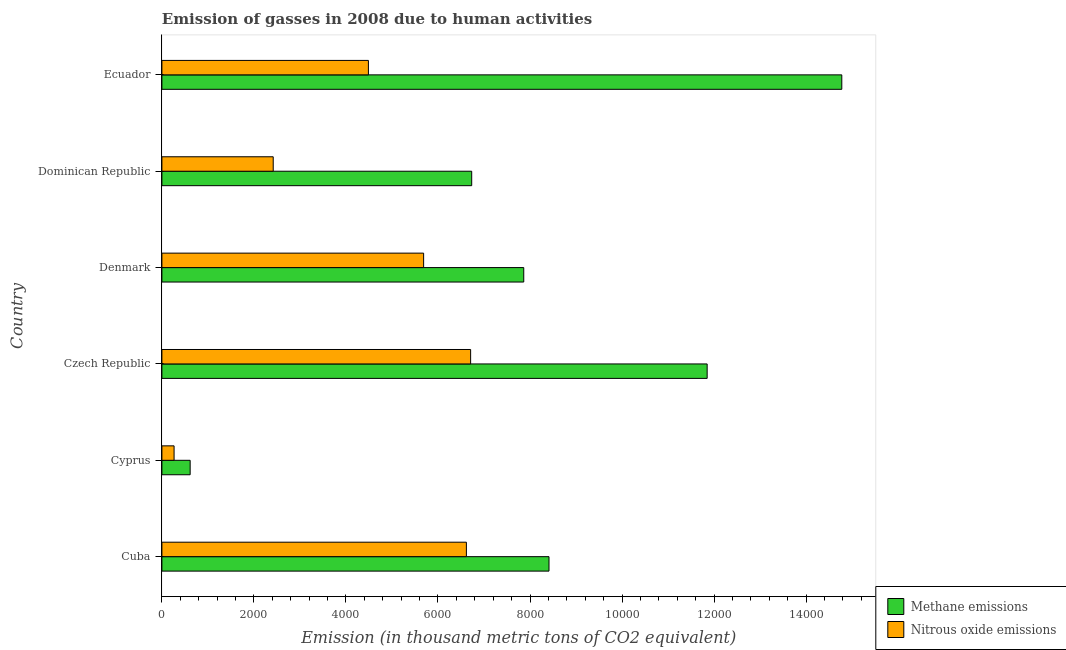Are the number of bars per tick equal to the number of legend labels?
Provide a short and direct response. Yes. What is the label of the 5th group of bars from the top?
Provide a succinct answer. Cyprus. What is the amount of methane emissions in Ecuador?
Your answer should be very brief. 1.48e+04. Across all countries, what is the maximum amount of methane emissions?
Your response must be concise. 1.48e+04. Across all countries, what is the minimum amount of methane emissions?
Ensure brevity in your answer.  614.2. In which country was the amount of methane emissions maximum?
Your answer should be compact. Ecuador. In which country was the amount of methane emissions minimum?
Make the answer very short. Cyprus. What is the total amount of methane emissions in the graph?
Provide a succinct answer. 5.03e+04. What is the difference between the amount of methane emissions in Cuba and that in Cyprus?
Provide a succinct answer. 7798.9. What is the difference between the amount of nitrous oxide emissions in Cyprus and the amount of methane emissions in Cuba?
Provide a short and direct response. -8148.6. What is the average amount of methane emissions per country?
Offer a terse response. 8375.22. What is the difference between the amount of nitrous oxide emissions and amount of methane emissions in Cuba?
Your response must be concise. -1795.6. In how many countries, is the amount of nitrous oxide emissions greater than 4800 thousand metric tons?
Keep it short and to the point. 3. What is the ratio of the amount of nitrous oxide emissions in Cuba to that in Denmark?
Offer a very short reply. 1.16. Is the difference between the amount of methane emissions in Cyprus and Ecuador greater than the difference between the amount of nitrous oxide emissions in Cyprus and Ecuador?
Your answer should be compact. No. What is the difference between the highest and the second highest amount of nitrous oxide emissions?
Provide a succinct answer. 92.2. What is the difference between the highest and the lowest amount of methane emissions?
Your answer should be compact. 1.42e+04. What does the 1st bar from the top in Czech Republic represents?
Make the answer very short. Nitrous oxide emissions. What does the 1st bar from the bottom in Cuba represents?
Provide a succinct answer. Methane emissions. How many bars are there?
Give a very brief answer. 12. Are all the bars in the graph horizontal?
Make the answer very short. Yes. How many countries are there in the graph?
Offer a very short reply. 6. What is the difference between two consecutive major ticks on the X-axis?
Offer a very short reply. 2000. Are the values on the major ticks of X-axis written in scientific E-notation?
Offer a terse response. No. Does the graph contain any zero values?
Provide a short and direct response. No. Does the graph contain grids?
Provide a succinct answer. No. Where does the legend appear in the graph?
Your response must be concise. Bottom right. How are the legend labels stacked?
Your answer should be compact. Vertical. What is the title of the graph?
Give a very brief answer. Emission of gasses in 2008 due to human activities. Does "Arms exports" appear as one of the legend labels in the graph?
Keep it short and to the point. No. What is the label or title of the X-axis?
Offer a terse response. Emission (in thousand metric tons of CO2 equivalent). What is the Emission (in thousand metric tons of CO2 equivalent) in Methane emissions in Cuba?
Offer a terse response. 8413.1. What is the Emission (in thousand metric tons of CO2 equivalent) in Nitrous oxide emissions in Cuba?
Your response must be concise. 6617.5. What is the Emission (in thousand metric tons of CO2 equivalent) in Methane emissions in Cyprus?
Your response must be concise. 614.2. What is the Emission (in thousand metric tons of CO2 equivalent) of Nitrous oxide emissions in Cyprus?
Provide a short and direct response. 264.5. What is the Emission (in thousand metric tons of CO2 equivalent) in Methane emissions in Czech Republic?
Provide a succinct answer. 1.19e+04. What is the Emission (in thousand metric tons of CO2 equivalent) of Nitrous oxide emissions in Czech Republic?
Offer a terse response. 6709.7. What is the Emission (in thousand metric tons of CO2 equivalent) of Methane emissions in Denmark?
Offer a very short reply. 7864.1. What is the Emission (in thousand metric tons of CO2 equivalent) in Nitrous oxide emissions in Denmark?
Provide a succinct answer. 5688.2. What is the Emission (in thousand metric tons of CO2 equivalent) in Methane emissions in Dominican Republic?
Provide a succinct answer. 6733.1. What is the Emission (in thousand metric tons of CO2 equivalent) in Nitrous oxide emissions in Dominican Republic?
Ensure brevity in your answer.  2419.2. What is the Emission (in thousand metric tons of CO2 equivalent) of Methane emissions in Ecuador?
Give a very brief answer. 1.48e+04. What is the Emission (in thousand metric tons of CO2 equivalent) in Nitrous oxide emissions in Ecuador?
Make the answer very short. 4488.1. Across all countries, what is the maximum Emission (in thousand metric tons of CO2 equivalent) of Methane emissions?
Offer a very short reply. 1.48e+04. Across all countries, what is the maximum Emission (in thousand metric tons of CO2 equivalent) in Nitrous oxide emissions?
Make the answer very short. 6709.7. Across all countries, what is the minimum Emission (in thousand metric tons of CO2 equivalent) of Methane emissions?
Offer a terse response. 614.2. Across all countries, what is the minimum Emission (in thousand metric tons of CO2 equivalent) in Nitrous oxide emissions?
Your response must be concise. 264.5. What is the total Emission (in thousand metric tons of CO2 equivalent) of Methane emissions in the graph?
Make the answer very short. 5.03e+04. What is the total Emission (in thousand metric tons of CO2 equivalent) in Nitrous oxide emissions in the graph?
Offer a terse response. 2.62e+04. What is the difference between the Emission (in thousand metric tons of CO2 equivalent) in Methane emissions in Cuba and that in Cyprus?
Your answer should be compact. 7798.9. What is the difference between the Emission (in thousand metric tons of CO2 equivalent) of Nitrous oxide emissions in Cuba and that in Cyprus?
Give a very brief answer. 6353. What is the difference between the Emission (in thousand metric tons of CO2 equivalent) in Methane emissions in Cuba and that in Czech Republic?
Offer a very short reply. -3437.3. What is the difference between the Emission (in thousand metric tons of CO2 equivalent) of Nitrous oxide emissions in Cuba and that in Czech Republic?
Offer a very short reply. -92.2. What is the difference between the Emission (in thousand metric tons of CO2 equivalent) in Methane emissions in Cuba and that in Denmark?
Your answer should be very brief. 549. What is the difference between the Emission (in thousand metric tons of CO2 equivalent) of Nitrous oxide emissions in Cuba and that in Denmark?
Offer a terse response. 929.3. What is the difference between the Emission (in thousand metric tons of CO2 equivalent) in Methane emissions in Cuba and that in Dominican Republic?
Provide a short and direct response. 1680. What is the difference between the Emission (in thousand metric tons of CO2 equivalent) of Nitrous oxide emissions in Cuba and that in Dominican Republic?
Provide a succinct answer. 4198.3. What is the difference between the Emission (in thousand metric tons of CO2 equivalent) in Methane emissions in Cuba and that in Ecuador?
Offer a terse response. -6363.3. What is the difference between the Emission (in thousand metric tons of CO2 equivalent) of Nitrous oxide emissions in Cuba and that in Ecuador?
Provide a short and direct response. 2129.4. What is the difference between the Emission (in thousand metric tons of CO2 equivalent) of Methane emissions in Cyprus and that in Czech Republic?
Ensure brevity in your answer.  -1.12e+04. What is the difference between the Emission (in thousand metric tons of CO2 equivalent) of Nitrous oxide emissions in Cyprus and that in Czech Republic?
Your answer should be very brief. -6445.2. What is the difference between the Emission (in thousand metric tons of CO2 equivalent) of Methane emissions in Cyprus and that in Denmark?
Your answer should be very brief. -7249.9. What is the difference between the Emission (in thousand metric tons of CO2 equivalent) of Nitrous oxide emissions in Cyprus and that in Denmark?
Provide a short and direct response. -5423.7. What is the difference between the Emission (in thousand metric tons of CO2 equivalent) of Methane emissions in Cyprus and that in Dominican Republic?
Keep it short and to the point. -6118.9. What is the difference between the Emission (in thousand metric tons of CO2 equivalent) in Nitrous oxide emissions in Cyprus and that in Dominican Republic?
Give a very brief answer. -2154.7. What is the difference between the Emission (in thousand metric tons of CO2 equivalent) in Methane emissions in Cyprus and that in Ecuador?
Ensure brevity in your answer.  -1.42e+04. What is the difference between the Emission (in thousand metric tons of CO2 equivalent) in Nitrous oxide emissions in Cyprus and that in Ecuador?
Provide a succinct answer. -4223.6. What is the difference between the Emission (in thousand metric tons of CO2 equivalent) in Methane emissions in Czech Republic and that in Denmark?
Give a very brief answer. 3986.3. What is the difference between the Emission (in thousand metric tons of CO2 equivalent) in Nitrous oxide emissions in Czech Republic and that in Denmark?
Make the answer very short. 1021.5. What is the difference between the Emission (in thousand metric tons of CO2 equivalent) in Methane emissions in Czech Republic and that in Dominican Republic?
Provide a succinct answer. 5117.3. What is the difference between the Emission (in thousand metric tons of CO2 equivalent) in Nitrous oxide emissions in Czech Republic and that in Dominican Republic?
Ensure brevity in your answer.  4290.5. What is the difference between the Emission (in thousand metric tons of CO2 equivalent) of Methane emissions in Czech Republic and that in Ecuador?
Your response must be concise. -2926. What is the difference between the Emission (in thousand metric tons of CO2 equivalent) of Nitrous oxide emissions in Czech Republic and that in Ecuador?
Provide a short and direct response. 2221.6. What is the difference between the Emission (in thousand metric tons of CO2 equivalent) in Methane emissions in Denmark and that in Dominican Republic?
Provide a short and direct response. 1131. What is the difference between the Emission (in thousand metric tons of CO2 equivalent) of Nitrous oxide emissions in Denmark and that in Dominican Republic?
Offer a terse response. 3269. What is the difference between the Emission (in thousand metric tons of CO2 equivalent) of Methane emissions in Denmark and that in Ecuador?
Offer a terse response. -6912.3. What is the difference between the Emission (in thousand metric tons of CO2 equivalent) in Nitrous oxide emissions in Denmark and that in Ecuador?
Your answer should be very brief. 1200.1. What is the difference between the Emission (in thousand metric tons of CO2 equivalent) in Methane emissions in Dominican Republic and that in Ecuador?
Your answer should be very brief. -8043.3. What is the difference between the Emission (in thousand metric tons of CO2 equivalent) in Nitrous oxide emissions in Dominican Republic and that in Ecuador?
Keep it short and to the point. -2068.9. What is the difference between the Emission (in thousand metric tons of CO2 equivalent) of Methane emissions in Cuba and the Emission (in thousand metric tons of CO2 equivalent) of Nitrous oxide emissions in Cyprus?
Provide a short and direct response. 8148.6. What is the difference between the Emission (in thousand metric tons of CO2 equivalent) in Methane emissions in Cuba and the Emission (in thousand metric tons of CO2 equivalent) in Nitrous oxide emissions in Czech Republic?
Your answer should be compact. 1703.4. What is the difference between the Emission (in thousand metric tons of CO2 equivalent) of Methane emissions in Cuba and the Emission (in thousand metric tons of CO2 equivalent) of Nitrous oxide emissions in Denmark?
Your response must be concise. 2724.9. What is the difference between the Emission (in thousand metric tons of CO2 equivalent) of Methane emissions in Cuba and the Emission (in thousand metric tons of CO2 equivalent) of Nitrous oxide emissions in Dominican Republic?
Give a very brief answer. 5993.9. What is the difference between the Emission (in thousand metric tons of CO2 equivalent) in Methane emissions in Cuba and the Emission (in thousand metric tons of CO2 equivalent) in Nitrous oxide emissions in Ecuador?
Provide a succinct answer. 3925. What is the difference between the Emission (in thousand metric tons of CO2 equivalent) of Methane emissions in Cyprus and the Emission (in thousand metric tons of CO2 equivalent) of Nitrous oxide emissions in Czech Republic?
Make the answer very short. -6095.5. What is the difference between the Emission (in thousand metric tons of CO2 equivalent) in Methane emissions in Cyprus and the Emission (in thousand metric tons of CO2 equivalent) in Nitrous oxide emissions in Denmark?
Your answer should be very brief. -5074. What is the difference between the Emission (in thousand metric tons of CO2 equivalent) in Methane emissions in Cyprus and the Emission (in thousand metric tons of CO2 equivalent) in Nitrous oxide emissions in Dominican Republic?
Your answer should be very brief. -1805. What is the difference between the Emission (in thousand metric tons of CO2 equivalent) of Methane emissions in Cyprus and the Emission (in thousand metric tons of CO2 equivalent) of Nitrous oxide emissions in Ecuador?
Give a very brief answer. -3873.9. What is the difference between the Emission (in thousand metric tons of CO2 equivalent) in Methane emissions in Czech Republic and the Emission (in thousand metric tons of CO2 equivalent) in Nitrous oxide emissions in Denmark?
Your response must be concise. 6162.2. What is the difference between the Emission (in thousand metric tons of CO2 equivalent) in Methane emissions in Czech Republic and the Emission (in thousand metric tons of CO2 equivalent) in Nitrous oxide emissions in Dominican Republic?
Your answer should be very brief. 9431.2. What is the difference between the Emission (in thousand metric tons of CO2 equivalent) of Methane emissions in Czech Republic and the Emission (in thousand metric tons of CO2 equivalent) of Nitrous oxide emissions in Ecuador?
Your answer should be very brief. 7362.3. What is the difference between the Emission (in thousand metric tons of CO2 equivalent) in Methane emissions in Denmark and the Emission (in thousand metric tons of CO2 equivalent) in Nitrous oxide emissions in Dominican Republic?
Your response must be concise. 5444.9. What is the difference between the Emission (in thousand metric tons of CO2 equivalent) in Methane emissions in Denmark and the Emission (in thousand metric tons of CO2 equivalent) in Nitrous oxide emissions in Ecuador?
Ensure brevity in your answer.  3376. What is the difference between the Emission (in thousand metric tons of CO2 equivalent) in Methane emissions in Dominican Republic and the Emission (in thousand metric tons of CO2 equivalent) in Nitrous oxide emissions in Ecuador?
Offer a terse response. 2245. What is the average Emission (in thousand metric tons of CO2 equivalent) in Methane emissions per country?
Provide a succinct answer. 8375.22. What is the average Emission (in thousand metric tons of CO2 equivalent) in Nitrous oxide emissions per country?
Keep it short and to the point. 4364.53. What is the difference between the Emission (in thousand metric tons of CO2 equivalent) of Methane emissions and Emission (in thousand metric tons of CO2 equivalent) of Nitrous oxide emissions in Cuba?
Make the answer very short. 1795.6. What is the difference between the Emission (in thousand metric tons of CO2 equivalent) in Methane emissions and Emission (in thousand metric tons of CO2 equivalent) in Nitrous oxide emissions in Cyprus?
Your answer should be very brief. 349.7. What is the difference between the Emission (in thousand metric tons of CO2 equivalent) in Methane emissions and Emission (in thousand metric tons of CO2 equivalent) in Nitrous oxide emissions in Czech Republic?
Give a very brief answer. 5140.7. What is the difference between the Emission (in thousand metric tons of CO2 equivalent) of Methane emissions and Emission (in thousand metric tons of CO2 equivalent) of Nitrous oxide emissions in Denmark?
Provide a short and direct response. 2175.9. What is the difference between the Emission (in thousand metric tons of CO2 equivalent) of Methane emissions and Emission (in thousand metric tons of CO2 equivalent) of Nitrous oxide emissions in Dominican Republic?
Provide a short and direct response. 4313.9. What is the difference between the Emission (in thousand metric tons of CO2 equivalent) in Methane emissions and Emission (in thousand metric tons of CO2 equivalent) in Nitrous oxide emissions in Ecuador?
Make the answer very short. 1.03e+04. What is the ratio of the Emission (in thousand metric tons of CO2 equivalent) of Methane emissions in Cuba to that in Cyprus?
Your response must be concise. 13.7. What is the ratio of the Emission (in thousand metric tons of CO2 equivalent) in Nitrous oxide emissions in Cuba to that in Cyprus?
Your answer should be compact. 25.02. What is the ratio of the Emission (in thousand metric tons of CO2 equivalent) of Methane emissions in Cuba to that in Czech Republic?
Provide a succinct answer. 0.71. What is the ratio of the Emission (in thousand metric tons of CO2 equivalent) of Nitrous oxide emissions in Cuba to that in Czech Republic?
Your answer should be very brief. 0.99. What is the ratio of the Emission (in thousand metric tons of CO2 equivalent) of Methane emissions in Cuba to that in Denmark?
Give a very brief answer. 1.07. What is the ratio of the Emission (in thousand metric tons of CO2 equivalent) of Nitrous oxide emissions in Cuba to that in Denmark?
Your answer should be compact. 1.16. What is the ratio of the Emission (in thousand metric tons of CO2 equivalent) of Methane emissions in Cuba to that in Dominican Republic?
Provide a short and direct response. 1.25. What is the ratio of the Emission (in thousand metric tons of CO2 equivalent) of Nitrous oxide emissions in Cuba to that in Dominican Republic?
Provide a succinct answer. 2.74. What is the ratio of the Emission (in thousand metric tons of CO2 equivalent) of Methane emissions in Cuba to that in Ecuador?
Offer a terse response. 0.57. What is the ratio of the Emission (in thousand metric tons of CO2 equivalent) of Nitrous oxide emissions in Cuba to that in Ecuador?
Keep it short and to the point. 1.47. What is the ratio of the Emission (in thousand metric tons of CO2 equivalent) of Methane emissions in Cyprus to that in Czech Republic?
Provide a succinct answer. 0.05. What is the ratio of the Emission (in thousand metric tons of CO2 equivalent) of Nitrous oxide emissions in Cyprus to that in Czech Republic?
Ensure brevity in your answer.  0.04. What is the ratio of the Emission (in thousand metric tons of CO2 equivalent) in Methane emissions in Cyprus to that in Denmark?
Your response must be concise. 0.08. What is the ratio of the Emission (in thousand metric tons of CO2 equivalent) in Nitrous oxide emissions in Cyprus to that in Denmark?
Provide a succinct answer. 0.05. What is the ratio of the Emission (in thousand metric tons of CO2 equivalent) in Methane emissions in Cyprus to that in Dominican Republic?
Offer a terse response. 0.09. What is the ratio of the Emission (in thousand metric tons of CO2 equivalent) of Nitrous oxide emissions in Cyprus to that in Dominican Republic?
Your response must be concise. 0.11. What is the ratio of the Emission (in thousand metric tons of CO2 equivalent) of Methane emissions in Cyprus to that in Ecuador?
Make the answer very short. 0.04. What is the ratio of the Emission (in thousand metric tons of CO2 equivalent) of Nitrous oxide emissions in Cyprus to that in Ecuador?
Your answer should be compact. 0.06. What is the ratio of the Emission (in thousand metric tons of CO2 equivalent) in Methane emissions in Czech Republic to that in Denmark?
Give a very brief answer. 1.51. What is the ratio of the Emission (in thousand metric tons of CO2 equivalent) in Nitrous oxide emissions in Czech Republic to that in Denmark?
Your response must be concise. 1.18. What is the ratio of the Emission (in thousand metric tons of CO2 equivalent) in Methane emissions in Czech Republic to that in Dominican Republic?
Offer a terse response. 1.76. What is the ratio of the Emission (in thousand metric tons of CO2 equivalent) in Nitrous oxide emissions in Czech Republic to that in Dominican Republic?
Make the answer very short. 2.77. What is the ratio of the Emission (in thousand metric tons of CO2 equivalent) in Methane emissions in Czech Republic to that in Ecuador?
Provide a succinct answer. 0.8. What is the ratio of the Emission (in thousand metric tons of CO2 equivalent) of Nitrous oxide emissions in Czech Republic to that in Ecuador?
Give a very brief answer. 1.5. What is the ratio of the Emission (in thousand metric tons of CO2 equivalent) of Methane emissions in Denmark to that in Dominican Republic?
Provide a short and direct response. 1.17. What is the ratio of the Emission (in thousand metric tons of CO2 equivalent) in Nitrous oxide emissions in Denmark to that in Dominican Republic?
Offer a very short reply. 2.35. What is the ratio of the Emission (in thousand metric tons of CO2 equivalent) of Methane emissions in Denmark to that in Ecuador?
Provide a succinct answer. 0.53. What is the ratio of the Emission (in thousand metric tons of CO2 equivalent) of Nitrous oxide emissions in Denmark to that in Ecuador?
Give a very brief answer. 1.27. What is the ratio of the Emission (in thousand metric tons of CO2 equivalent) of Methane emissions in Dominican Republic to that in Ecuador?
Your answer should be very brief. 0.46. What is the ratio of the Emission (in thousand metric tons of CO2 equivalent) of Nitrous oxide emissions in Dominican Republic to that in Ecuador?
Offer a terse response. 0.54. What is the difference between the highest and the second highest Emission (in thousand metric tons of CO2 equivalent) in Methane emissions?
Give a very brief answer. 2926. What is the difference between the highest and the second highest Emission (in thousand metric tons of CO2 equivalent) of Nitrous oxide emissions?
Your answer should be compact. 92.2. What is the difference between the highest and the lowest Emission (in thousand metric tons of CO2 equivalent) in Methane emissions?
Your answer should be compact. 1.42e+04. What is the difference between the highest and the lowest Emission (in thousand metric tons of CO2 equivalent) in Nitrous oxide emissions?
Ensure brevity in your answer.  6445.2. 